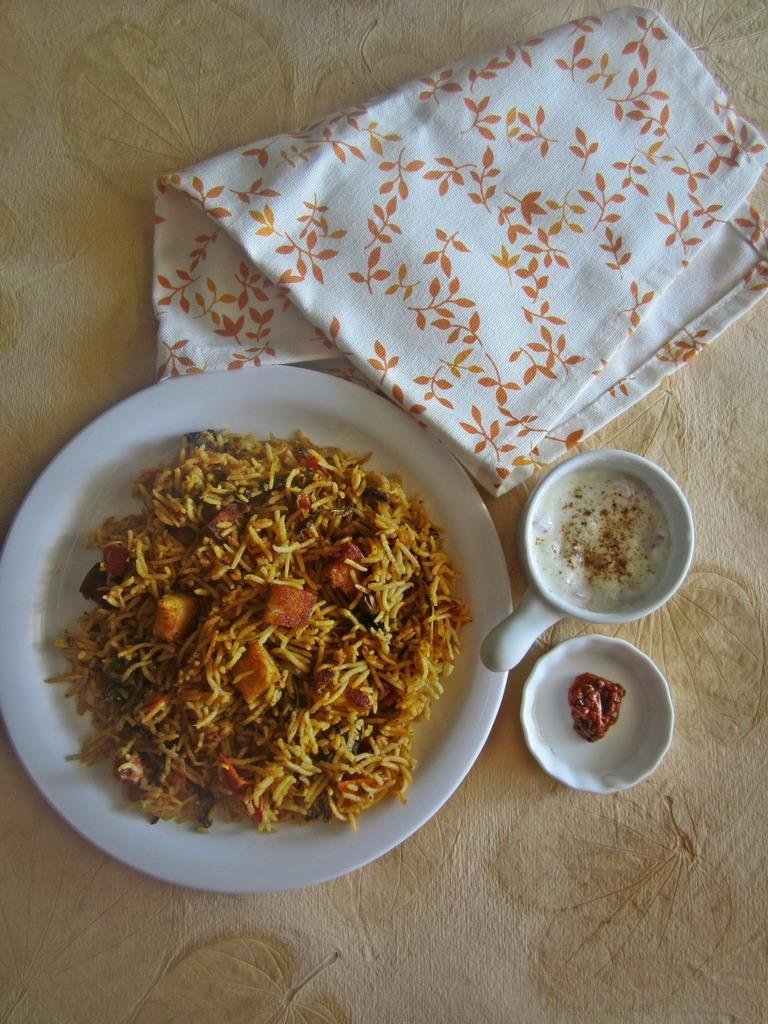What type of food is in the plate in the image? There is rice in a plate in the image. What accompanies the rice on the table? There is a small plate with pickle beside the rice. What beverage might be consumed from the cup in the image? There is a coffee cup in the image, suggesting that coffee might be consumed. What item is present for cleaning or wiping in the image? There is a napkin in the image. Where are all the items located in the image? All items are on a table. What type of bone is visible in the image? There is no bone present in the image. How many clovers are on the table in the image? There are no clovers present in the image. 